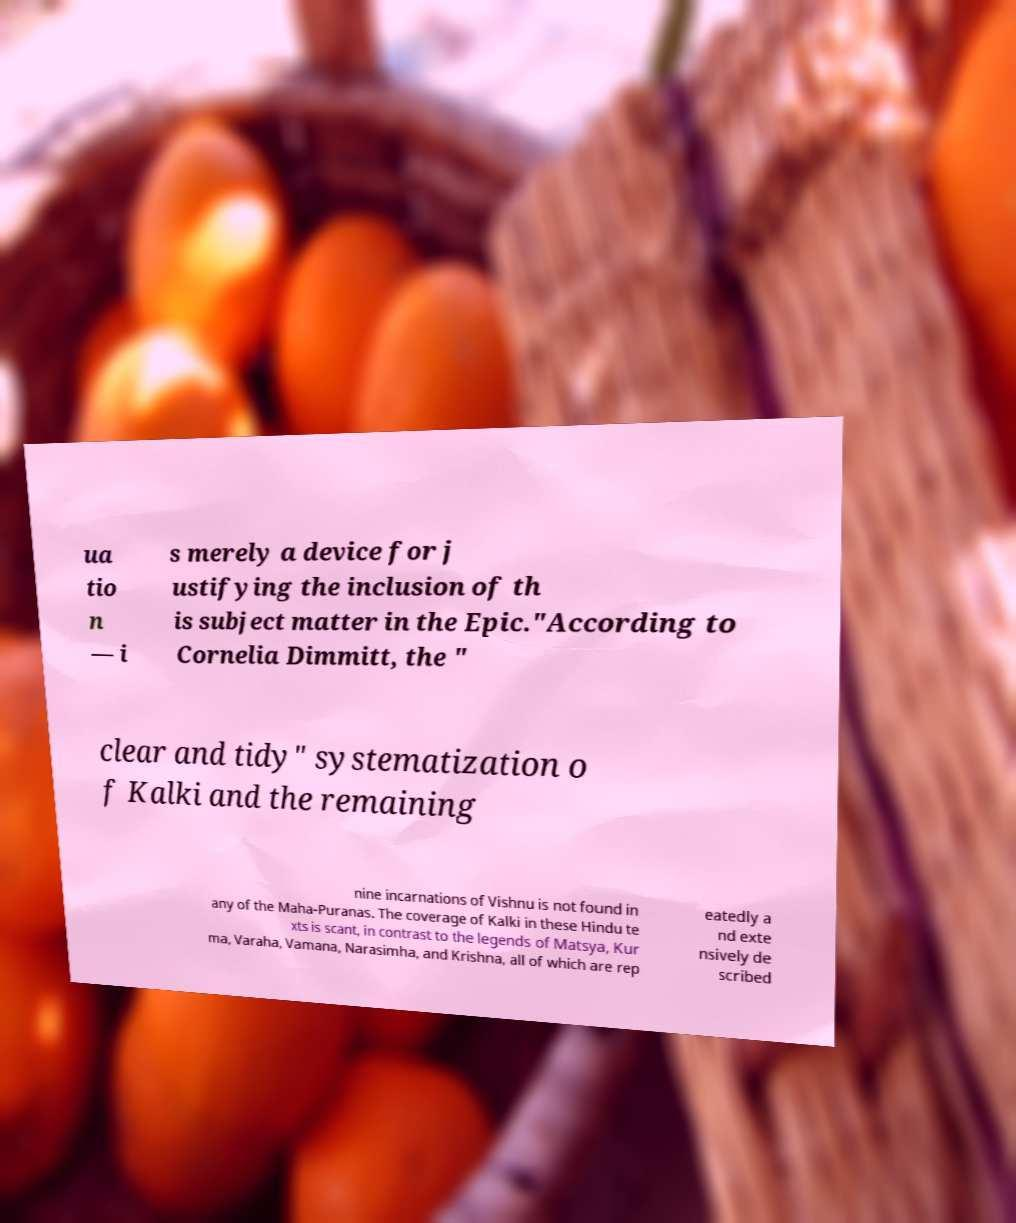There's text embedded in this image that I need extracted. Can you transcribe it verbatim? ua tio n — i s merely a device for j ustifying the inclusion of th is subject matter in the Epic."According to Cornelia Dimmitt, the " clear and tidy" systematization o f Kalki and the remaining nine incarnations of Vishnu is not found in any of the Maha-Puranas. The coverage of Kalki in these Hindu te xts is scant, in contrast to the legends of Matsya, Kur ma, Varaha, Vamana, Narasimha, and Krishna, all of which are rep eatedly a nd exte nsively de scribed 